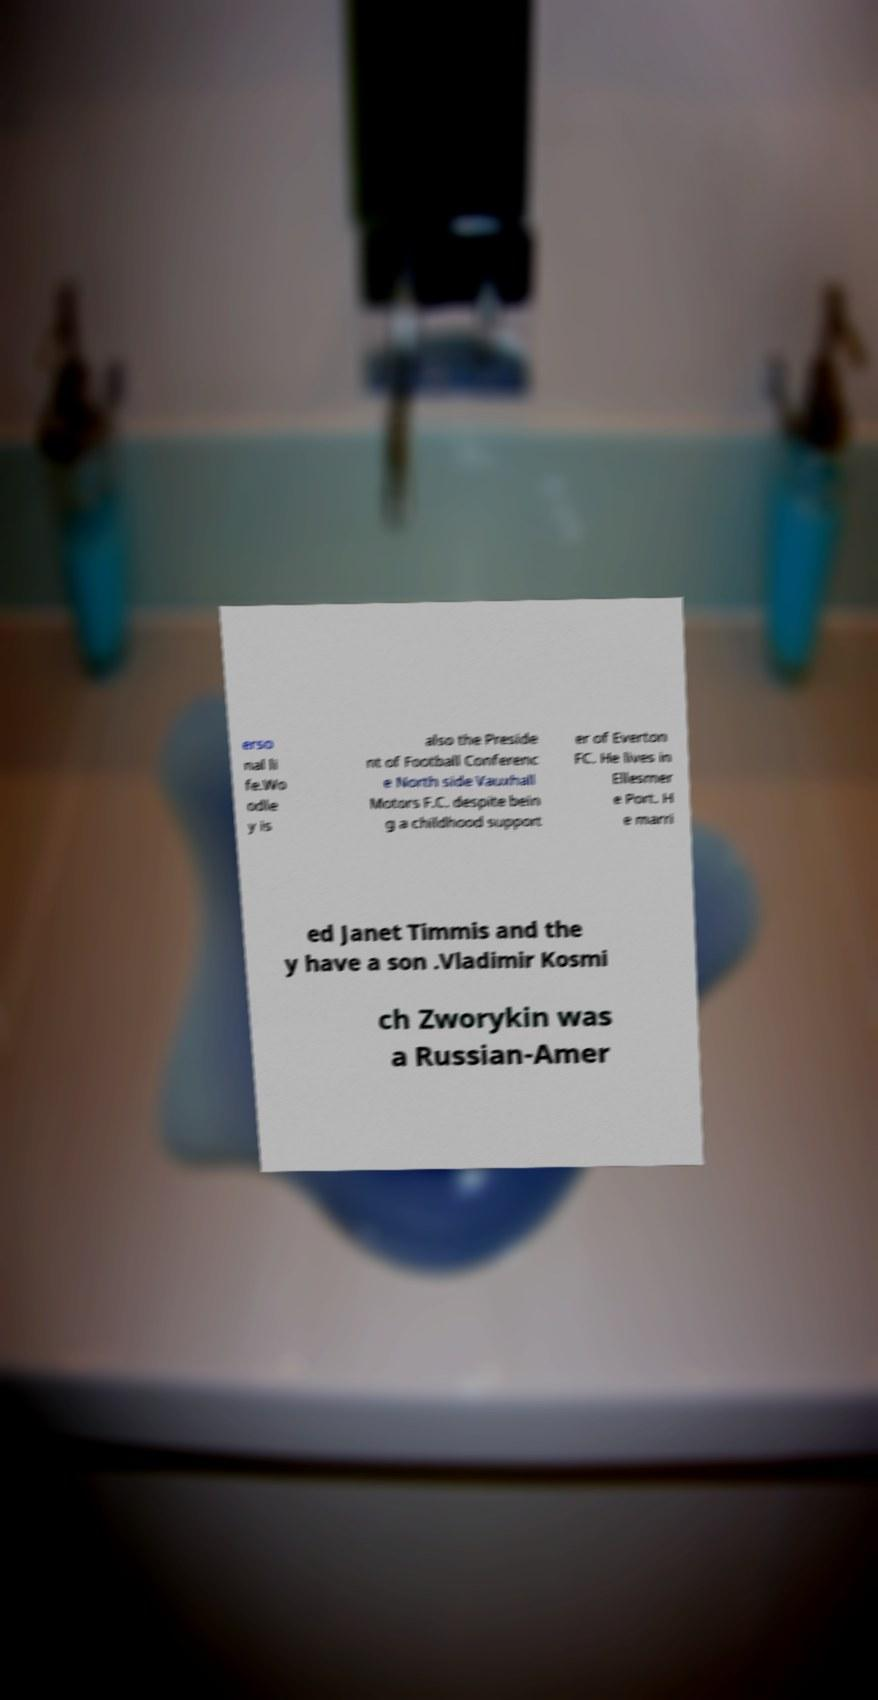Could you assist in decoding the text presented in this image and type it out clearly? erso nal li fe.Wo odle y is also the Preside nt of Football Conferenc e North side Vauxhall Motors F.C. despite bein g a childhood support er of Everton FC. He lives in Ellesmer e Port. H e marri ed Janet Timmis and the y have a son .Vladimir Kosmi ch Zworykin was a Russian-Amer 